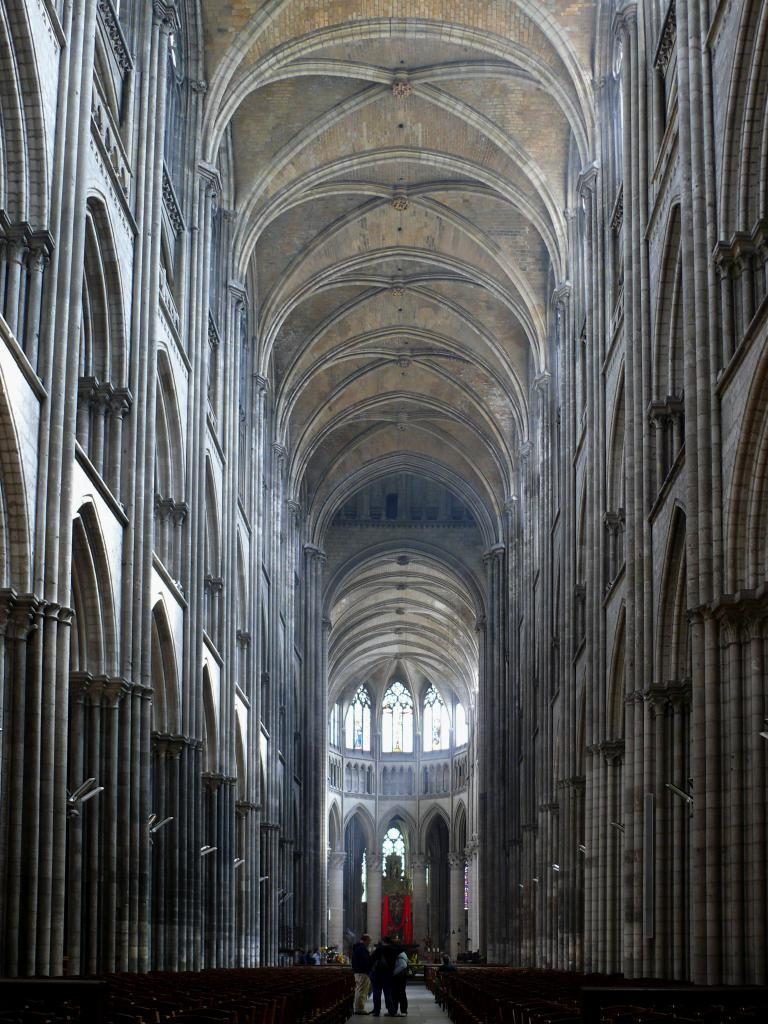What type of location is depicted in the image? The image is an inside view of a building. What architectural features can be seen on the sides of the image? There are pillars on the right and left sides of the image. What type of furniture is present on the floor? There are benches on the floor. Are there any people in the image? Yes, there are people standing in the image. What type of silk fabric is draped over the loaf in the image? There is no loaf or silk fabric present in the image. 